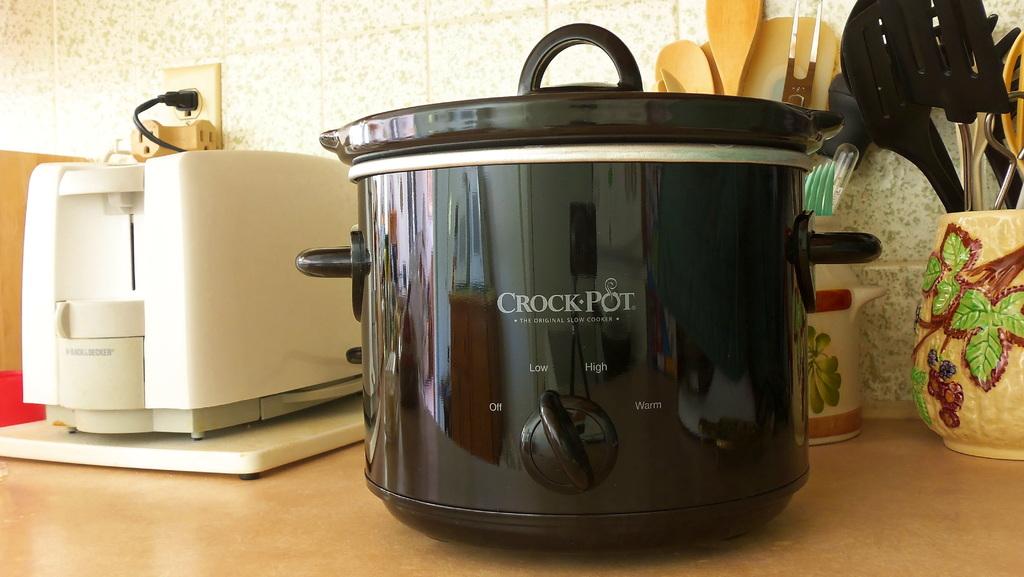What setting is the crock pot on?
Keep it short and to the point. Low. What color is the crock pot?
Offer a very short reply. Black. 